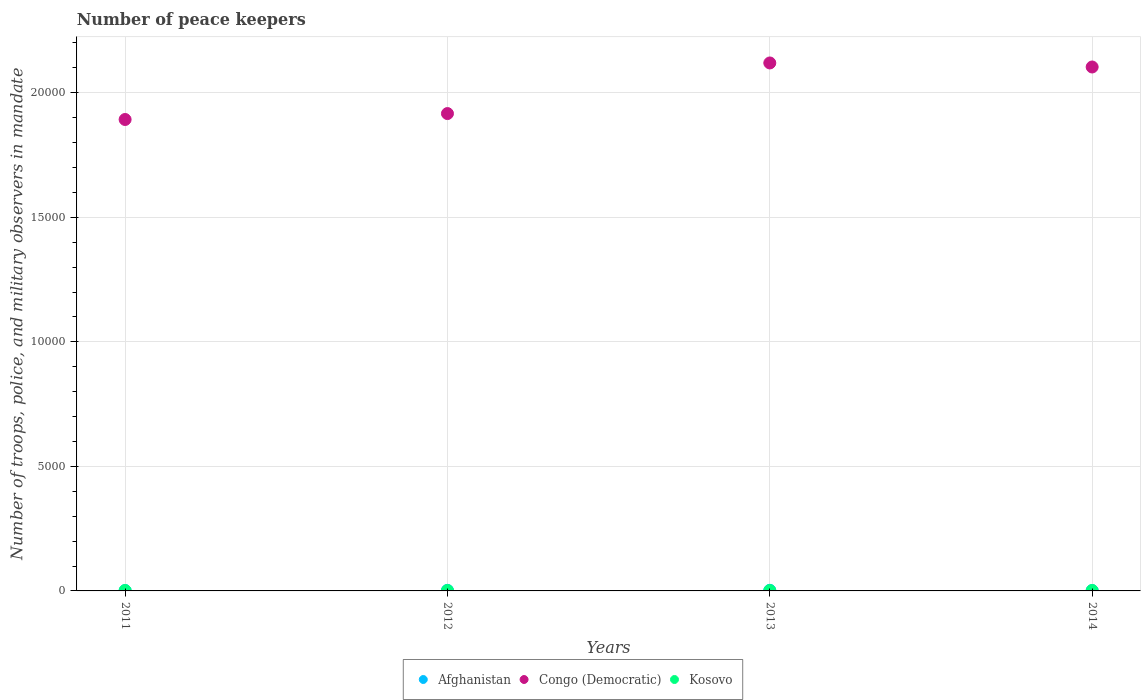Is the number of dotlines equal to the number of legend labels?
Give a very brief answer. Yes. Across all years, what is the maximum number of peace keepers in in Congo (Democratic)?
Offer a terse response. 2.12e+04. In which year was the number of peace keepers in in Afghanistan maximum?
Make the answer very short. 2013. In which year was the number of peace keepers in in Afghanistan minimum?
Offer a terse response. 2011. What is the total number of peace keepers in in Afghanistan in the graph?
Your response must be concise. 78. What is the difference between the number of peace keepers in in Kosovo in 2011 and the number of peace keepers in in Congo (Democratic) in 2014?
Keep it short and to the point. -2.10e+04. What is the average number of peace keepers in in Congo (Democratic) per year?
Provide a succinct answer. 2.01e+04. In the year 2013, what is the difference between the number of peace keepers in in Congo (Democratic) and number of peace keepers in in Kosovo?
Your answer should be compact. 2.12e+04. In how many years, is the number of peace keepers in in Afghanistan greater than 17000?
Make the answer very short. 0. Is the number of peace keepers in in Congo (Democratic) in 2011 less than that in 2012?
Offer a terse response. Yes. What is the difference between the highest and the lowest number of peace keepers in in Congo (Democratic)?
Make the answer very short. 2270. Is the sum of the number of peace keepers in in Congo (Democratic) in 2012 and 2013 greater than the maximum number of peace keepers in in Afghanistan across all years?
Your response must be concise. Yes. Is it the case that in every year, the sum of the number of peace keepers in in Afghanistan and number of peace keepers in in Kosovo  is greater than the number of peace keepers in in Congo (Democratic)?
Your answer should be compact. No. Does the number of peace keepers in in Kosovo monotonically increase over the years?
Offer a very short reply. No. How many dotlines are there?
Your response must be concise. 3. How many years are there in the graph?
Keep it short and to the point. 4. What is the difference between two consecutive major ticks on the Y-axis?
Provide a succinct answer. 5000. Does the graph contain grids?
Provide a succinct answer. Yes. How many legend labels are there?
Provide a succinct answer. 3. What is the title of the graph?
Your response must be concise. Number of peace keepers. What is the label or title of the X-axis?
Provide a succinct answer. Years. What is the label or title of the Y-axis?
Offer a terse response. Number of troops, police, and military observers in mandate. What is the Number of troops, police, and military observers in mandate of Congo (Democratic) in 2011?
Offer a very short reply. 1.89e+04. What is the Number of troops, police, and military observers in mandate in Congo (Democratic) in 2012?
Ensure brevity in your answer.  1.92e+04. What is the Number of troops, police, and military observers in mandate in Congo (Democratic) in 2013?
Make the answer very short. 2.12e+04. What is the Number of troops, police, and military observers in mandate in Kosovo in 2013?
Your response must be concise. 14. What is the Number of troops, police, and military observers in mandate in Afghanistan in 2014?
Offer a terse response. 15. What is the Number of troops, police, and military observers in mandate in Congo (Democratic) in 2014?
Provide a short and direct response. 2.10e+04. What is the Number of troops, police, and military observers in mandate of Kosovo in 2014?
Offer a terse response. 16. Across all years, what is the maximum Number of troops, police, and military observers in mandate in Afghanistan?
Your answer should be very brief. 25. Across all years, what is the maximum Number of troops, police, and military observers in mandate of Congo (Democratic)?
Keep it short and to the point. 2.12e+04. Across all years, what is the minimum Number of troops, police, and military observers in mandate of Afghanistan?
Keep it short and to the point. 15. Across all years, what is the minimum Number of troops, police, and military observers in mandate in Congo (Democratic)?
Provide a succinct answer. 1.89e+04. Across all years, what is the minimum Number of troops, police, and military observers in mandate in Kosovo?
Your answer should be compact. 14. What is the total Number of troops, police, and military observers in mandate in Congo (Democratic) in the graph?
Provide a short and direct response. 8.03e+04. What is the difference between the Number of troops, police, and military observers in mandate of Afghanistan in 2011 and that in 2012?
Make the answer very short. -8. What is the difference between the Number of troops, police, and military observers in mandate of Congo (Democratic) in 2011 and that in 2012?
Offer a very short reply. -238. What is the difference between the Number of troops, police, and military observers in mandate in Afghanistan in 2011 and that in 2013?
Offer a very short reply. -10. What is the difference between the Number of troops, police, and military observers in mandate of Congo (Democratic) in 2011 and that in 2013?
Keep it short and to the point. -2270. What is the difference between the Number of troops, police, and military observers in mandate of Afghanistan in 2011 and that in 2014?
Give a very brief answer. 0. What is the difference between the Number of troops, police, and military observers in mandate of Congo (Democratic) in 2011 and that in 2014?
Your response must be concise. -2108. What is the difference between the Number of troops, police, and military observers in mandate of Congo (Democratic) in 2012 and that in 2013?
Keep it short and to the point. -2032. What is the difference between the Number of troops, police, and military observers in mandate of Congo (Democratic) in 2012 and that in 2014?
Make the answer very short. -1870. What is the difference between the Number of troops, police, and military observers in mandate of Afghanistan in 2013 and that in 2014?
Make the answer very short. 10. What is the difference between the Number of troops, police, and military observers in mandate of Congo (Democratic) in 2013 and that in 2014?
Provide a succinct answer. 162. What is the difference between the Number of troops, police, and military observers in mandate of Afghanistan in 2011 and the Number of troops, police, and military observers in mandate of Congo (Democratic) in 2012?
Provide a succinct answer. -1.92e+04. What is the difference between the Number of troops, police, and military observers in mandate in Congo (Democratic) in 2011 and the Number of troops, police, and military observers in mandate in Kosovo in 2012?
Ensure brevity in your answer.  1.89e+04. What is the difference between the Number of troops, police, and military observers in mandate in Afghanistan in 2011 and the Number of troops, police, and military observers in mandate in Congo (Democratic) in 2013?
Give a very brief answer. -2.12e+04. What is the difference between the Number of troops, police, and military observers in mandate in Congo (Democratic) in 2011 and the Number of troops, police, and military observers in mandate in Kosovo in 2013?
Offer a terse response. 1.89e+04. What is the difference between the Number of troops, police, and military observers in mandate of Afghanistan in 2011 and the Number of troops, police, and military observers in mandate of Congo (Democratic) in 2014?
Ensure brevity in your answer.  -2.10e+04. What is the difference between the Number of troops, police, and military observers in mandate of Afghanistan in 2011 and the Number of troops, police, and military observers in mandate of Kosovo in 2014?
Provide a succinct answer. -1. What is the difference between the Number of troops, police, and military observers in mandate in Congo (Democratic) in 2011 and the Number of troops, police, and military observers in mandate in Kosovo in 2014?
Give a very brief answer. 1.89e+04. What is the difference between the Number of troops, police, and military observers in mandate of Afghanistan in 2012 and the Number of troops, police, and military observers in mandate of Congo (Democratic) in 2013?
Keep it short and to the point. -2.12e+04. What is the difference between the Number of troops, police, and military observers in mandate in Afghanistan in 2012 and the Number of troops, police, and military observers in mandate in Kosovo in 2013?
Your answer should be compact. 9. What is the difference between the Number of troops, police, and military observers in mandate in Congo (Democratic) in 2012 and the Number of troops, police, and military observers in mandate in Kosovo in 2013?
Provide a succinct answer. 1.92e+04. What is the difference between the Number of troops, police, and military observers in mandate in Afghanistan in 2012 and the Number of troops, police, and military observers in mandate in Congo (Democratic) in 2014?
Your response must be concise. -2.10e+04. What is the difference between the Number of troops, police, and military observers in mandate of Congo (Democratic) in 2012 and the Number of troops, police, and military observers in mandate of Kosovo in 2014?
Your answer should be very brief. 1.92e+04. What is the difference between the Number of troops, police, and military observers in mandate in Afghanistan in 2013 and the Number of troops, police, and military observers in mandate in Congo (Democratic) in 2014?
Your answer should be compact. -2.10e+04. What is the difference between the Number of troops, police, and military observers in mandate in Congo (Democratic) in 2013 and the Number of troops, police, and military observers in mandate in Kosovo in 2014?
Offer a very short reply. 2.12e+04. What is the average Number of troops, police, and military observers in mandate in Afghanistan per year?
Offer a very short reply. 19.5. What is the average Number of troops, police, and military observers in mandate of Congo (Democratic) per year?
Offer a very short reply. 2.01e+04. What is the average Number of troops, police, and military observers in mandate of Kosovo per year?
Provide a succinct answer. 15.5. In the year 2011, what is the difference between the Number of troops, police, and military observers in mandate of Afghanistan and Number of troops, police, and military observers in mandate of Congo (Democratic)?
Give a very brief answer. -1.89e+04. In the year 2011, what is the difference between the Number of troops, police, and military observers in mandate of Afghanistan and Number of troops, police, and military observers in mandate of Kosovo?
Ensure brevity in your answer.  -1. In the year 2011, what is the difference between the Number of troops, police, and military observers in mandate in Congo (Democratic) and Number of troops, police, and military observers in mandate in Kosovo?
Offer a terse response. 1.89e+04. In the year 2012, what is the difference between the Number of troops, police, and military observers in mandate of Afghanistan and Number of troops, police, and military observers in mandate of Congo (Democratic)?
Provide a succinct answer. -1.91e+04. In the year 2012, what is the difference between the Number of troops, police, and military observers in mandate in Congo (Democratic) and Number of troops, police, and military observers in mandate in Kosovo?
Provide a short and direct response. 1.92e+04. In the year 2013, what is the difference between the Number of troops, police, and military observers in mandate in Afghanistan and Number of troops, police, and military observers in mandate in Congo (Democratic)?
Give a very brief answer. -2.12e+04. In the year 2013, what is the difference between the Number of troops, police, and military observers in mandate in Afghanistan and Number of troops, police, and military observers in mandate in Kosovo?
Provide a short and direct response. 11. In the year 2013, what is the difference between the Number of troops, police, and military observers in mandate of Congo (Democratic) and Number of troops, police, and military observers in mandate of Kosovo?
Your answer should be compact. 2.12e+04. In the year 2014, what is the difference between the Number of troops, police, and military observers in mandate of Afghanistan and Number of troops, police, and military observers in mandate of Congo (Democratic)?
Make the answer very short. -2.10e+04. In the year 2014, what is the difference between the Number of troops, police, and military observers in mandate in Congo (Democratic) and Number of troops, police, and military observers in mandate in Kosovo?
Provide a succinct answer. 2.10e+04. What is the ratio of the Number of troops, police, and military observers in mandate in Afghanistan in 2011 to that in 2012?
Your response must be concise. 0.65. What is the ratio of the Number of troops, police, and military observers in mandate in Congo (Democratic) in 2011 to that in 2012?
Your response must be concise. 0.99. What is the ratio of the Number of troops, police, and military observers in mandate in Afghanistan in 2011 to that in 2013?
Your response must be concise. 0.6. What is the ratio of the Number of troops, police, and military observers in mandate of Congo (Democratic) in 2011 to that in 2013?
Keep it short and to the point. 0.89. What is the ratio of the Number of troops, police, and military observers in mandate of Kosovo in 2011 to that in 2013?
Your answer should be compact. 1.14. What is the ratio of the Number of troops, police, and military observers in mandate of Afghanistan in 2011 to that in 2014?
Your answer should be very brief. 1. What is the ratio of the Number of troops, police, and military observers in mandate in Congo (Democratic) in 2011 to that in 2014?
Offer a terse response. 0.9. What is the ratio of the Number of troops, police, and military observers in mandate of Kosovo in 2011 to that in 2014?
Provide a succinct answer. 1. What is the ratio of the Number of troops, police, and military observers in mandate of Afghanistan in 2012 to that in 2013?
Offer a terse response. 0.92. What is the ratio of the Number of troops, police, and military observers in mandate of Congo (Democratic) in 2012 to that in 2013?
Provide a short and direct response. 0.9. What is the ratio of the Number of troops, police, and military observers in mandate in Kosovo in 2012 to that in 2013?
Give a very brief answer. 1.14. What is the ratio of the Number of troops, police, and military observers in mandate in Afghanistan in 2012 to that in 2014?
Ensure brevity in your answer.  1.53. What is the ratio of the Number of troops, police, and military observers in mandate of Congo (Democratic) in 2012 to that in 2014?
Provide a succinct answer. 0.91. What is the ratio of the Number of troops, police, and military observers in mandate of Kosovo in 2012 to that in 2014?
Keep it short and to the point. 1. What is the ratio of the Number of troops, police, and military observers in mandate of Afghanistan in 2013 to that in 2014?
Ensure brevity in your answer.  1.67. What is the ratio of the Number of troops, police, and military observers in mandate of Congo (Democratic) in 2013 to that in 2014?
Ensure brevity in your answer.  1.01. What is the difference between the highest and the second highest Number of troops, police, and military observers in mandate in Afghanistan?
Give a very brief answer. 2. What is the difference between the highest and the second highest Number of troops, police, and military observers in mandate of Congo (Democratic)?
Your answer should be compact. 162. What is the difference between the highest and the lowest Number of troops, police, and military observers in mandate of Congo (Democratic)?
Offer a terse response. 2270. What is the difference between the highest and the lowest Number of troops, police, and military observers in mandate of Kosovo?
Your answer should be very brief. 2. 